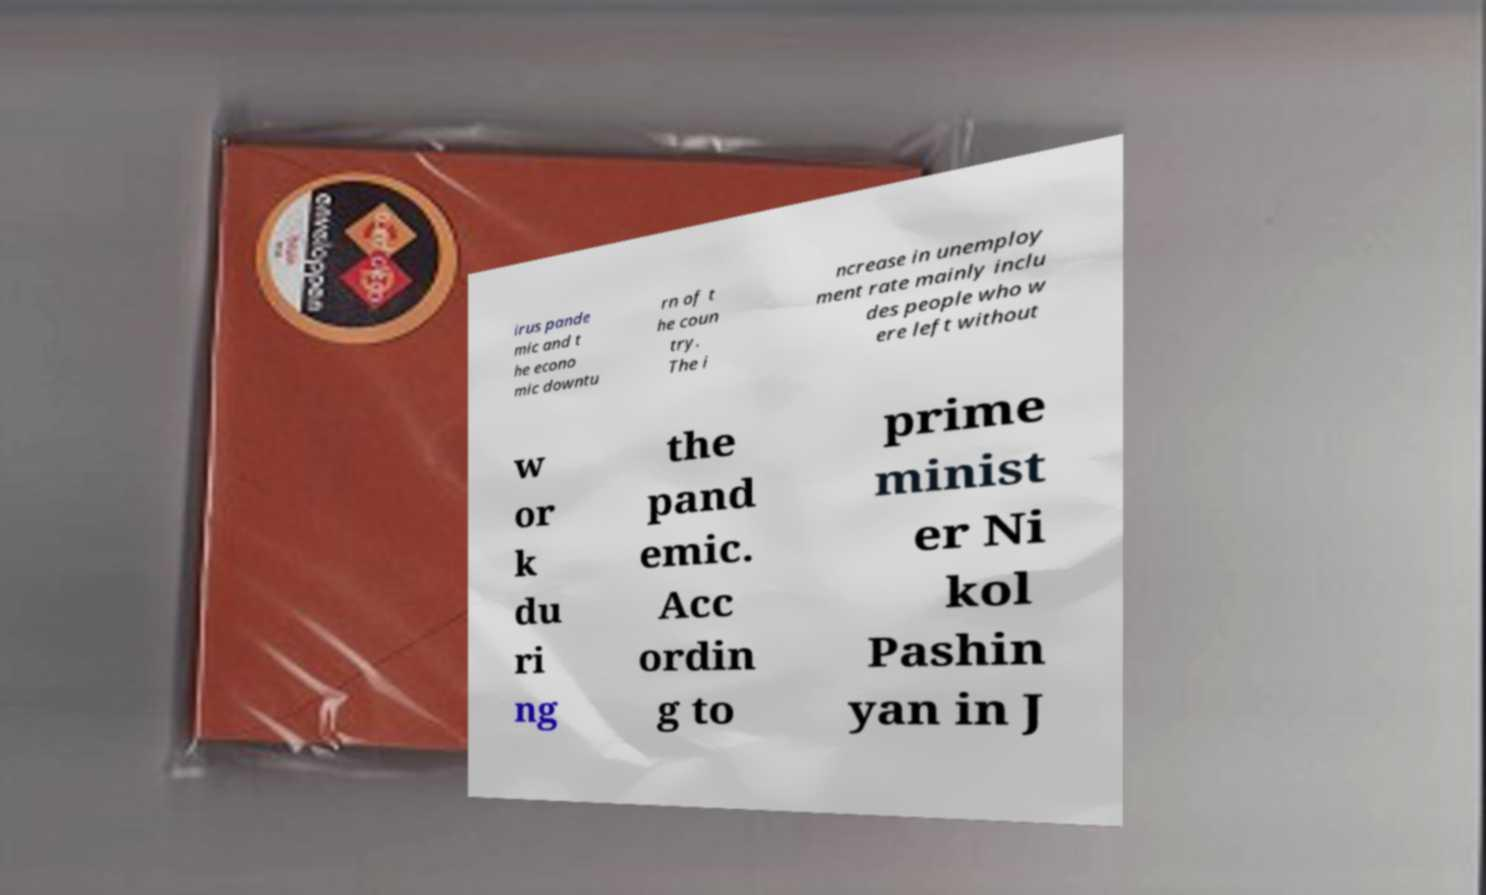I need the written content from this picture converted into text. Can you do that? irus pande mic and t he econo mic downtu rn of t he coun try. The i ncrease in unemploy ment rate mainly inclu des people who w ere left without w or k du ri ng the pand emic. Acc ordin g to prime minist er Ni kol Pashin yan in J 